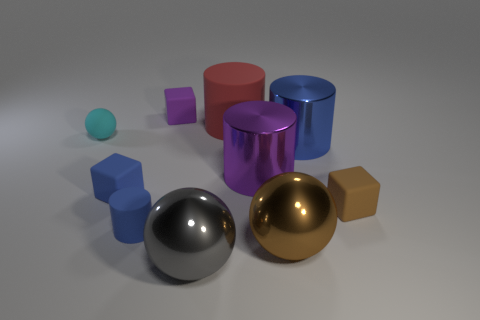There is a large metal thing that is behind the purple metal thing that is behind the blue matte object that is behind the small brown matte object; what is its shape?
Your answer should be compact. Cylinder. How many other things are there of the same color as the big matte cylinder?
Keep it short and to the point. 0. Are there more cylinders right of the cyan rubber sphere than big red matte cylinders that are right of the large brown object?
Offer a terse response. Yes. There is a big gray object; are there any tiny blue things on the left side of it?
Your response must be concise. Yes. There is a large object that is both left of the purple shiny thing and in front of the red cylinder; what is its material?
Offer a very short reply. Metal. There is another small object that is the same shape as the brown metallic thing; what is its color?
Offer a very short reply. Cyan. There is a sphere to the left of the small rubber cylinder; is there a cylinder behind it?
Provide a succinct answer. Yes. How big is the cyan object?
Make the answer very short. Small. What is the shape of the rubber object that is right of the large gray metal ball and behind the small blue cube?
Offer a terse response. Cylinder. What number of green things are small matte things or rubber blocks?
Provide a succinct answer. 0. 